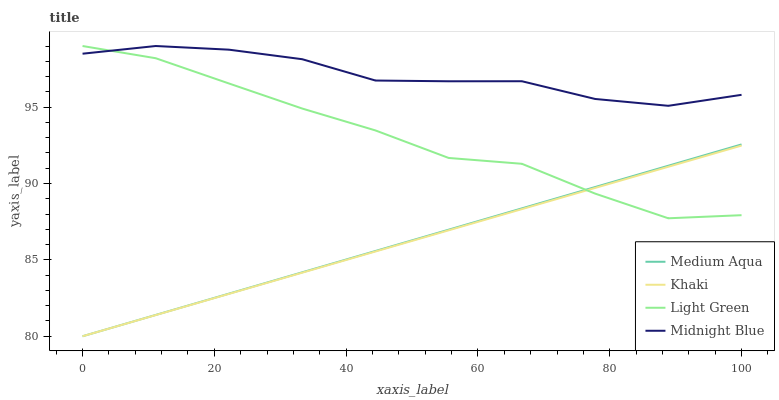Does Medium Aqua have the minimum area under the curve?
Answer yes or no. No. Does Medium Aqua have the maximum area under the curve?
Answer yes or no. No. Is Medium Aqua the smoothest?
Answer yes or no. No. Is Medium Aqua the roughest?
Answer yes or no. No. Does Midnight Blue have the lowest value?
Answer yes or no. No. Does Medium Aqua have the highest value?
Answer yes or no. No. Is Khaki less than Midnight Blue?
Answer yes or no. Yes. Is Midnight Blue greater than Khaki?
Answer yes or no. Yes. Does Khaki intersect Midnight Blue?
Answer yes or no. No. 